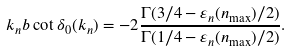<formula> <loc_0><loc_0><loc_500><loc_500>k _ { n } b \cot \delta _ { 0 } ( k _ { n } ) = - 2 \frac { \Gamma ( 3 / 4 - \varepsilon _ { n } ( n _ { \max } ) / 2 ) } { \Gamma ( 1 / 4 - \varepsilon _ { n } ( n _ { \max } ) / 2 ) } .</formula> 